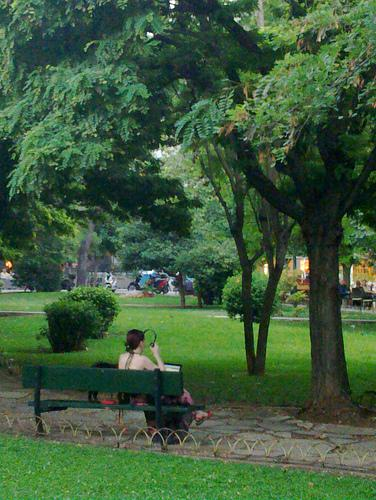Question: who is on the bench?
Choices:
A. A teenager.
B. A girl.
C. The woman.
D. A man.
Answer with the letter. Answer: C Question: what is on the woman's lap?
Choices:
A. A laptop.
B. A book.
C. A computer.
D. A tablet.
Answer with the letter. Answer: C Question: why is there a bench?
Choices:
A. For decoration.
B. For people to sit down.
C. For gatherings.
D. For picnics.
Answer with the letter. Answer: B 